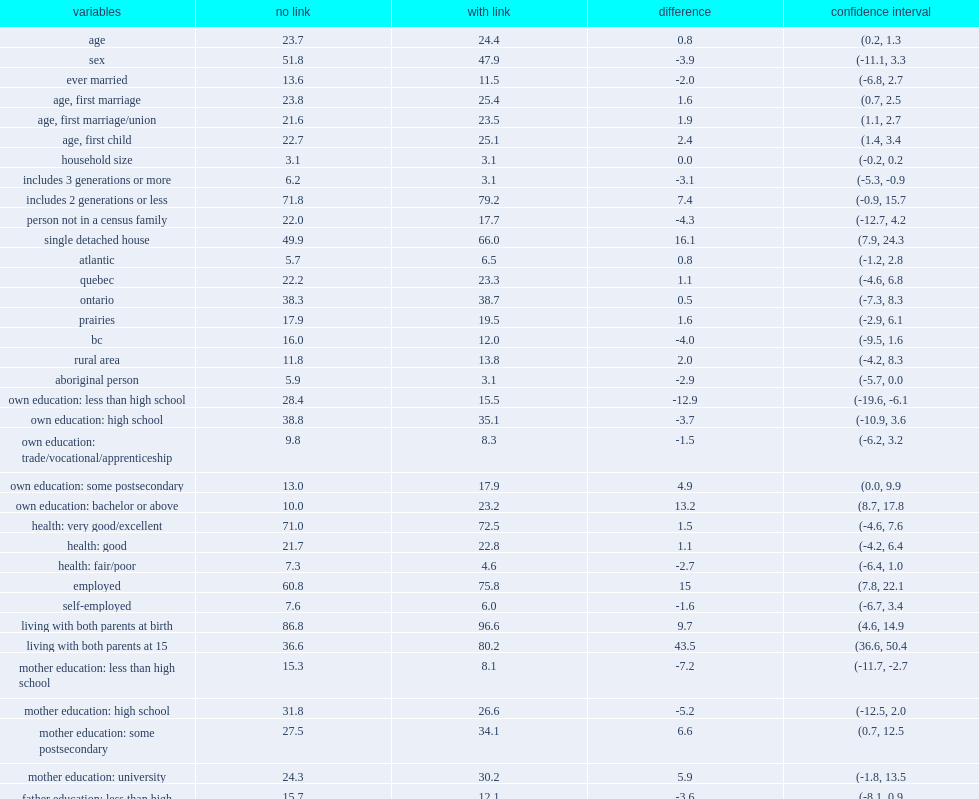What is the employment gap by success of parental linkage among the younger cohort? 15.0. How many percent of those with a successful linkage are more likely to have lived with both parents at birth? 9.7. How many percent of those with a successful linkage are more likely to have lived with both parents at age 15? 43.5. How many percent of respondents with a parent-child link are more likely to live in a single detached home at the time of the wave 2 survey? 16.1. 